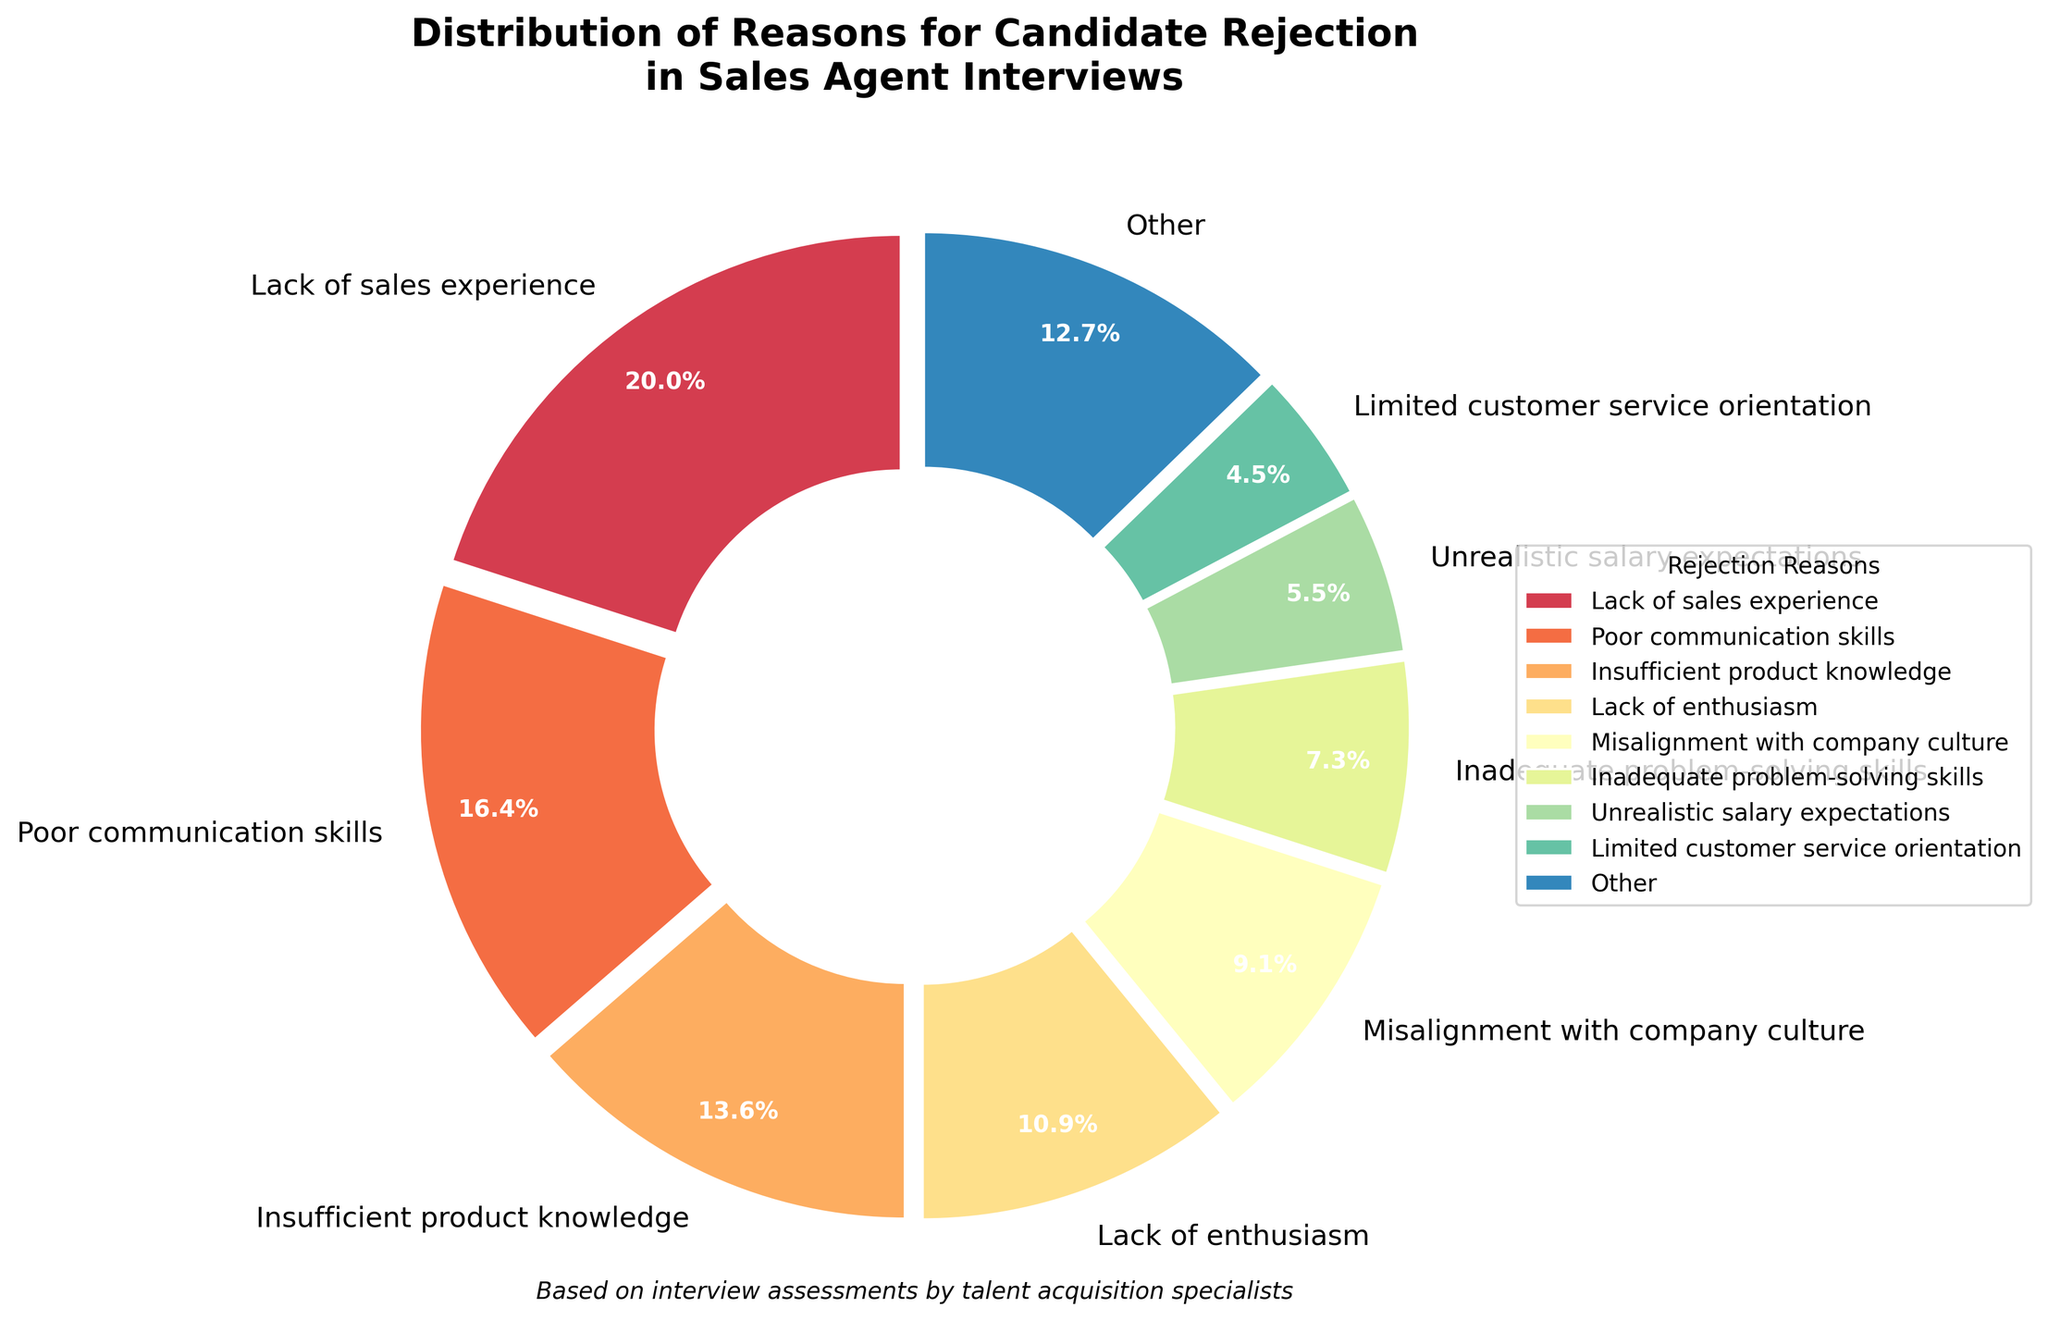What is the most common reason for candidate rejection? The largest segment in the pie chart represents the most common reason for candidate rejection, which is "Lack of sales experience."
Answer: Lack of sales experience What is the combined percentage of candidates rejected due to poor communication skills and inadequate problem-solving skills? The chart shows 18% for poor communication skills and 8% for inadequate problem-solving skills. Summing these percentages, 18 + 8 = 26%.
Answer: 26% How does the percentage of candidates rejected for insufficient product knowledge compare to those rejected for misalignment with company culture? The chart shows 15% for insufficient product knowledge and 10% for misalignment with company culture. Since 15% is greater than 10%, more candidates are rejected due to insufficient product knowledge.
Answer: Insufficient product knowledge is greater Which reasons fall under the "Other" category and what is their combined percentage? Reasons with smaller percentages such as limited customer service orientation, weak negotiation skills, lack of industry knowledge, poor time management, insufficient tech proficiency, inability to handle rejection, and lack of teamwork skills fall under "Other." Their individual percentages sum up to form the "Other" category.
Answer: 16% What percentage of candidates were rejected due to reasons related to skills (e.g., communication, problem-solving, tech proficiency)? Adding the percentages of poor communication skills (18%), inadequate problem-solving skills (8%), insufficient tech proficiency (2%), and weak negotiation skills (4%), we get 18 + 8 + 2 + 4 = 32%.
Answer: 32% Which reason has a smaller percentage: Lack of enthusiasm or unrealistic salary expectations? The chart shows that lack of enthusiasm accounts for 12%, whereas unrealistic salary expectations account for 6%. Therefore, unrealistic salary expectations have a smaller percentage.
Answer: Unrealistic salary expectations What is the total percentage of candidates rejected due to lack of sales experience and misalignment with company culture? Adding the percentages of lack of sales experience (22%) and misalignment with company culture (10%), we get 22 + 10 = 32%.
Answer: 32% How does the percentage for inadequate problem-solving skills compare visually to lack of industry knowledge? Inadequate problem-solving skills (8%) is visually represented with a larger segment in the pie chart compared to lack of industry knowledge (3%).
Answer: Inadequate problem-solving skills is larger If we combine the percentages of lack of teamwork skills, inability to handle rejection, and poor time management, what is the total? Adding the percentages of lack of teamwork skills (1%), inability to handle rejection (2%), and poor time management (2%), we get 1 + 2 + 2 = 5%.
Answer: 5% What can you infer about the importance of sales experience in candidate selection? Since the largest segment of the pie chart (22%) is for lack of sales experience, it indicates that sales experience is highly prioritized in candidate selection.
Answer: Sales experience is highly prioritized 